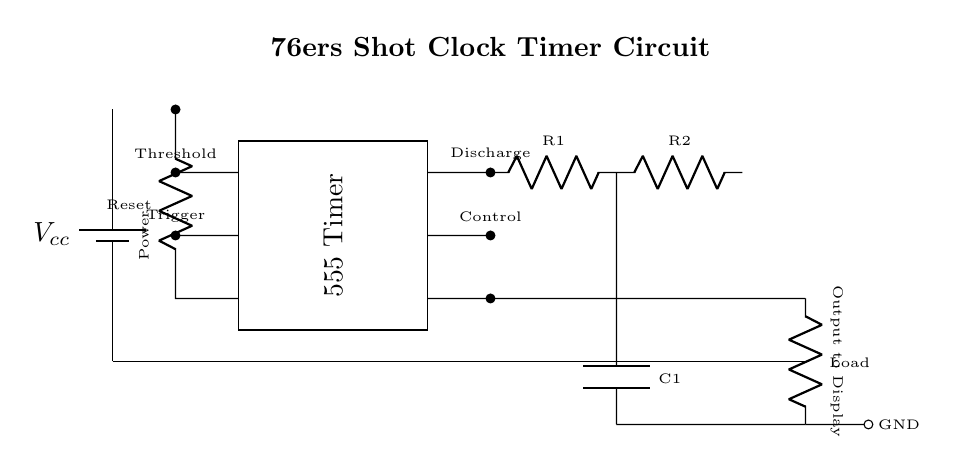What is the power supply voltage? The power supply, labeled as Vcc, is shown at the left side of the circuit diagram, typically indicating the voltage supply for the circuit components. The value is usually specified on the circuit; however, it is not provided in the diagram. Therefore, the answer is conceptual based on standard practices.
Answer: Vcc What is the function of the 555 Timer? The 555 Timer is widely used for timing applications, specifically to generate precise time delays or oscillate between states. It can operate in various configurations, and in this circuit, it likely serves to control the shot clock timing mechanism.
Answer: Timing How many resistors are present in the circuit? The circuit diagram shows two resistors labeled R1 and R2. By counting the components visually, we find that only these two resistors are present in the timer circuit.
Answer: Two What is the role of the capacitor in this circuit? The capacitor, labeled C1, is connected in parallel with one of the resistors and is essential for controlling the timing interval of the 555 Timer. It stores charge and releases it, impacting the timing cycle of the circuit.
Answer: Timing control What is the output of the circuit connected to? The output, indicated in the circuit, connects to a load, which can represent a display device or signal that indicates the remaining time on the shot clock. Following the path from the output notation leads directly to the load connection.
Answer: Load How does the Reset pin affect the circuit operation? The Reset pin is a control feature that can stop the operation of the timer by grounding it. If the reset signal is activated, the timer halts its counting and will need to be released to resume normal operation. This pin is crucial for the functionality of the shot clock, allowing for resets when necessary during gameplay.
Answer: Stops operation What type of circuit is depicted in this diagram? The circuit diagram represents a timer circuit specifically designed for a shot clock in basketball. The elements present, including a 555 Timer and timing components, denote its purpose geared towards controlling time intervals per the game rules.
Answer: Timer circuit 